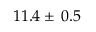Convert formula to latex. <formula><loc_0><loc_0><loc_500><loc_500>1 1 . 4 \pm \, 0 . 5</formula> 